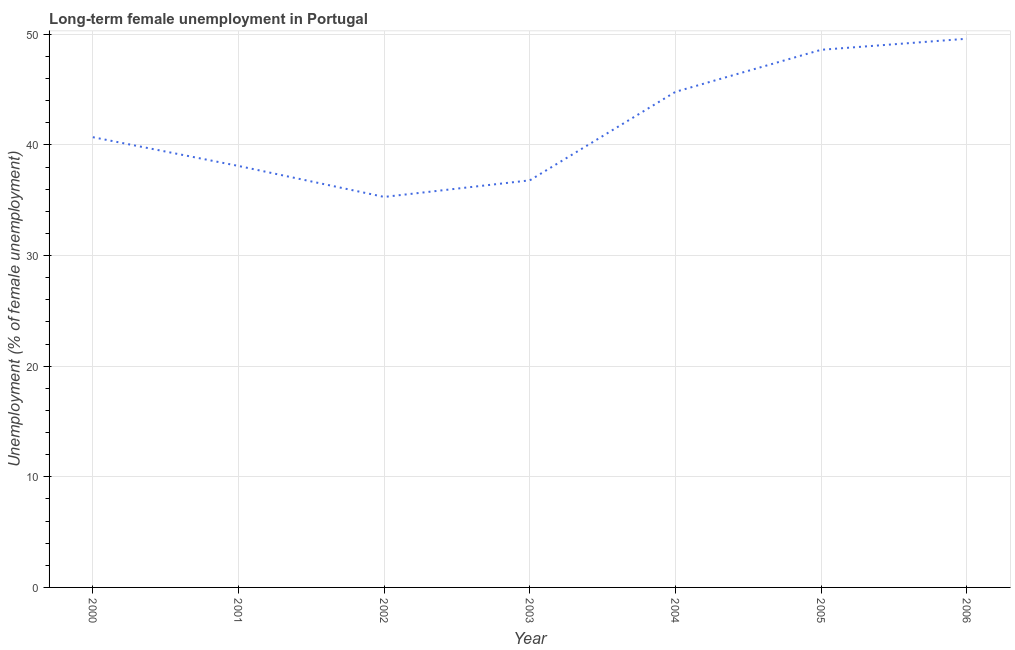What is the long-term female unemployment in 2006?
Your answer should be compact. 49.6. Across all years, what is the maximum long-term female unemployment?
Ensure brevity in your answer.  49.6. Across all years, what is the minimum long-term female unemployment?
Provide a succinct answer. 35.3. In which year was the long-term female unemployment maximum?
Your answer should be compact. 2006. In which year was the long-term female unemployment minimum?
Make the answer very short. 2002. What is the sum of the long-term female unemployment?
Your answer should be compact. 293.9. What is the difference between the long-term female unemployment in 2003 and 2004?
Give a very brief answer. -8. What is the average long-term female unemployment per year?
Provide a short and direct response. 41.99. What is the median long-term female unemployment?
Give a very brief answer. 40.7. What is the ratio of the long-term female unemployment in 2001 to that in 2005?
Ensure brevity in your answer.  0.78. Is the sum of the long-term female unemployment in 2000 and 2004 greater than the maximum long-term female unemployment across all years?
Make the answer very short. Yes. What is the difference between the highest and the lowest long-term female unemployment?
Make the answer very short. 14.3. In how many years, is the long-term female unemployment greater than the average long-term female unemployment taken over all years?
Offer a very short reply. 3. Does the long-term female unemployment monotonically increase over the years?
Keep it short and to the point. No. How many years are there in the graph?
Offer a very short reply. 7. Are the values on the major ticks of Y-axis written in scientific E-notation?
Offer a very short reply. No. Does the graph contain any zero values?
Offer a terse response. No. What is the title of the graph?
Provide a short and direct response. Long-term female unemployment in Portugal. What is the label or title of the Y-axis?
Ensure brevity in your answer.  Unemployment (% of female unemployment). What is the Unemployment (% of female unemployment) of 2000?
Offer a very short reply. 40.7. What is the Unemployment (% of female unemployment) of 2001?
Make the answer very short. 38.1. What is the Unemployment (% of female unemployment) in 2002?
Provide a succinct answer. 35.3. What is the Unemployment (% of female unemployment) in 2003?
Ensure brevity in your answer.  36.8. What is the Unemployment (% of female unemployment) in 2004?
Your answer should be very brief. 44.8. What is the Unemployment (% of female unemployment) in 2005?
Your response must be concise. 48.6. What is the Unemployment (% of female unemployment) in 2006?
Provide a short and direct response. 49.6. What is the difference between the Unemployment (% of female unemployment) in 2000 and 2002?
Your answer should be compact. 5.4. What is the difference between the Unemployment (% of female unemployment) in 2000 and 2004?
Keep it short and to the point. -4.1. What is the difference between the Unemployment (% of female unemployment) in 2000 and 2005?
Make the answer very short. -7.9. What is the difference between the Unemployment (% of female unemployment) in 2000 and 2006?
Provide a short and direct response. -8.9. What is the difference between the Unemployment (% of female unemployment) in 2001 and 2002?
Make the answer very short. 2.8. What is the difference between the Unemployment (% of female unemployment) in 2002 and 2003?
Give a very brief answer. -1.5. What is the difference between the Unemployment (% of female unemployment) in 2002 and 2004?
Offer a terse response. -9.5. What is the difference between the Unemployment (% of female unemployment) in 2002 and 2006?
Give a very brief answer. -14.3. What is the difference between the Unemployment (% of female unemployment) in 2003 and 2004?
Keep it short and to the point. -8. What is the difference between the Unemployment (% of female unemployment) in 2003 and 2005?
Provide a short and direct response. -11.8. What is the difference between the Unemployment (% of female unemployment) in 2004 and 2005?
Make the answer very short. -3.8. What is the difference between the Unemployment (% of female unemployment) in 2004 and 2006?
Keep it short and to the point. -4.8. What is the ratio of the Unemployment (% of female unemployment) in 2000 to that in 2001?
Make the answer very short. 1.07. What is the ratio of the Unemployment (% of female unemployment) in 2000 to that in 2002?
Keep it short and to the point. 1.15. What is the ratio of the Unemployment (% of female unemployment) in 2000 to that in 2003?
Keep it short and to the point. 1.11. What is the ratio of the Unemployment (% of female unemployment) in 2000 to that in 2004?
Your response must be concise. 0.91. What is the ratio of the Unemployment (% of female unemployment) in 2000 to that in 2005?
Your answer should be compact. 0.84. What is the ratio of the Unemployment (% of female unemployment) in 2000 to that in 2006?
Offer a terse response. 0.82. What is the ratio of the Unemployment (% of female unemployment) in 2001 to that in 2002?
Keep it short and to the point. 1.08. What is the ratio of the Unemployment (% of female unemployment) in 2001 to that in 2003?
Provide a succinct answer. 1.03. What is the ratio of the Unemployment (% of female unemployment) in 2001 to that in 2005?
Offer a very short reply. 0.78. What is the ratio of the Unemployment (% of female unemployment) in 2001 to that in 2006?
Your answer should be compact. 0.77. What is the ratio of the Unemployment (% of female unemployment) in 2002 to that in 2004?
Offer a terse response. 0.79. What is the ratio of the Unemployment (% of female unemployment) in 2002 to that in 2005?
Offer a terse response. 0.73. What is the ratio of the Unemployment (% of female unemployment) in 2002 to that in 2006?
Provide a short and direct response. 0.71. What is the ratio of the Unemployment (% of female unemployment) in 2003 to that in 2004?
Your answer should be very brief. 0.82. What is the ratio of the Unemployment (% of female unemployment) in 2003 to that in 2005?
Provide a succinct answer. 0.76. What is the ratio of the Unemployment (% of female unemployment) in 2003 to that in 2006?
Give a very brief answer. 0.74. What is the ratio of the Unemployment (% of female unemployment) in 2004 to that in 2005?
Give a very brief answer. 0.92. What is the ratio of the Unemployment (% of female unemployment) in 2004 to that in 2006?
Provide a succinct answer. 0.9. What is the ratio of the Unemployment (% of female unemployment) in 2005 to that in 2006?
Your answer should be very brief. 0.98. 